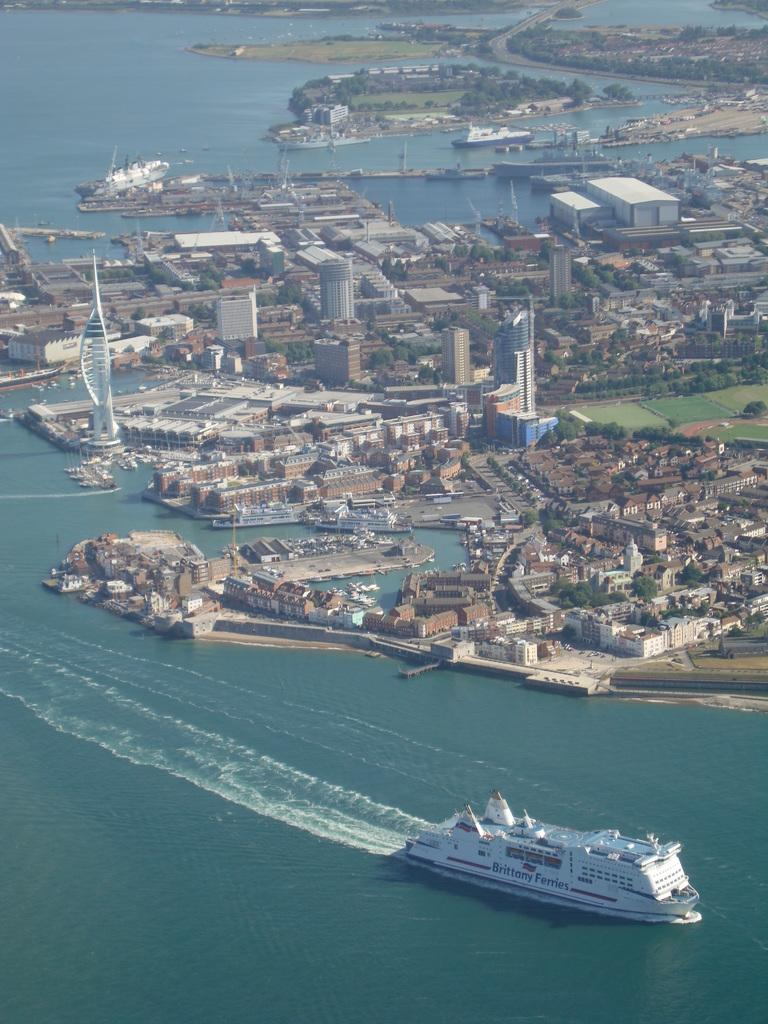What is in the water in the image? There are ships in the water in the image. What else can be seen in the image besides the ships? There are buildings and trees visible in the image. What type of pleasure can be seen reading a tank in the image in the picture? There is no pleasure, reading, or tank present in the image; it features ships in the water, buildings, and trees. 